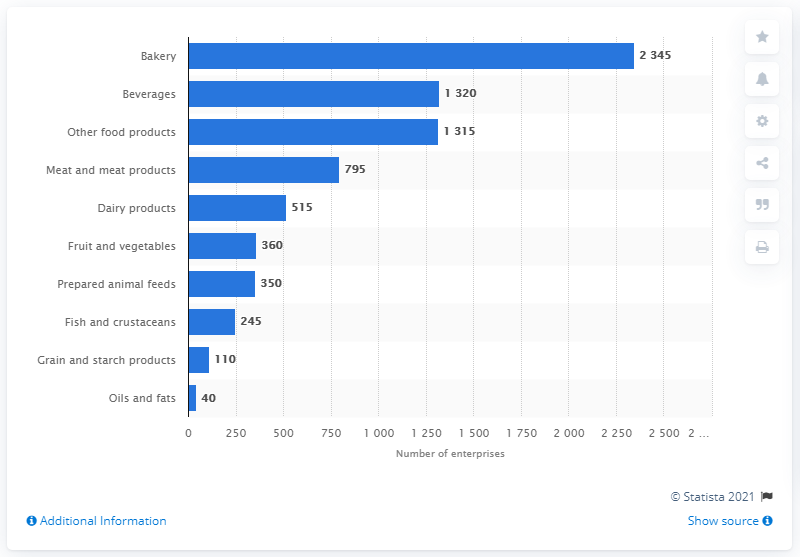Outline some significant characteristics in this image. In 2019, there were 515 small and medium-sized enterprises (SMEs) in the UK that produced dairy products. In 2019, 40 small and medium-sized enterprises (SMEs) in the UK were involved in the production of oils and fats. 